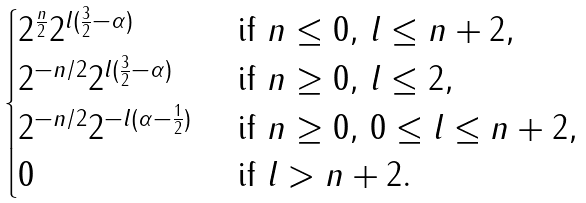<formula> <loc_0><loc_0><loc_500><loc_500>\begin{cases} 2 ^ { \frac { n } { 2 } } 2 ^ { l ( \frac { 3 } { 2 } - \alpha ) } & \text { if } n \leq 0 , \, l \leq n + 2 , \\ 2 ^ { - n / 2 } 2 ^ { l ( \frac { 3 } { 2 } - \alpha ) } & \text { if } n \geq 0 , \, l \leq 2 , \\ 2 ^ { - n / 2 } 2 ^ { - l ( \alpha - \frac { 1 } { 2 } ) } & \text { if } n \geq 0 , \, 0 \leq l \leq n + 2 , \\ 0 & \text { if } l > n + 2 . \end{cases}</formula> 